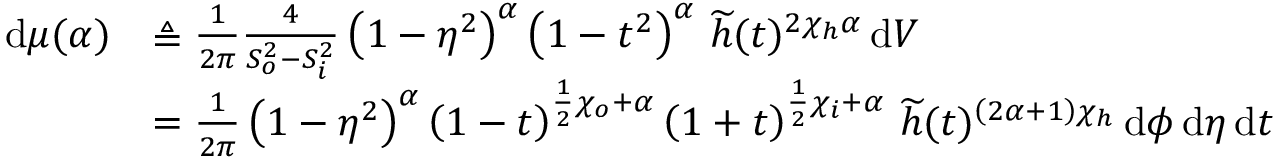Convert formula to latex. <formula><loc_0><loc_0><loc_500><loc_500>\begin{array} { r l } { \, d \mu ( \alpha ) } & { \triangle q \frac { 1 } { 2 \pi } \frac { 4 } { S _ { o } ^ { 2 } - S _ { i } ^ { 2 } } \left ( 1 - \eta ^ { 2 } \right ) ^ { \alpha } \left ( 1 - t ^ { 2 } \right ) ^ { \alpha } \, \widetilde { h } ( t ) ^ { 2 \chi _ { h } \alpha } \, d V } \\ & { = \frac { 1 } { 2 \pi } \left ( 1 - \eta ^ { 2 } \right ) ^ { \alpha } \left ( 1 - t \right ) ^ { \frac { 1 } { 2 } \chi _ { o } + \alpha } \left ( 1 + t \right ) ^ { \frac { 1 } { 2 } \chi _ { i } + \alpha } \, \widetilde { h } ( t ) ^ { \left ( 2 \alpha + 1 \right ) \chi _ { h } } \, d \phi \, d \eta \, d t } \end{array}</formula> 